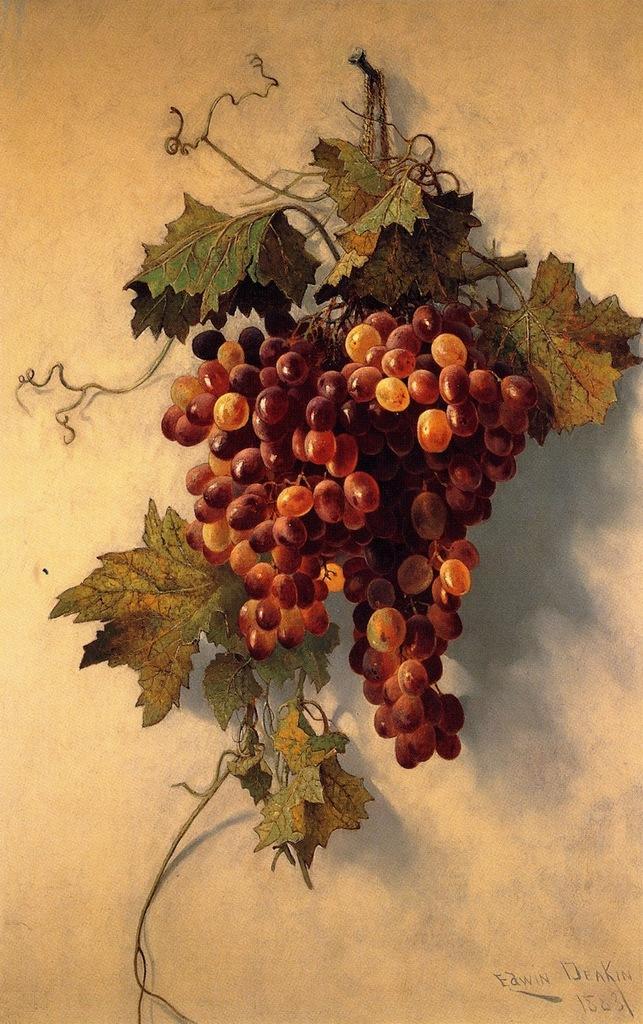How would you summarize this image in a sentence or two? This image consists of a painting of grapes and leaves along with the stems. The background is in white color. In the bottom right there is some text. 